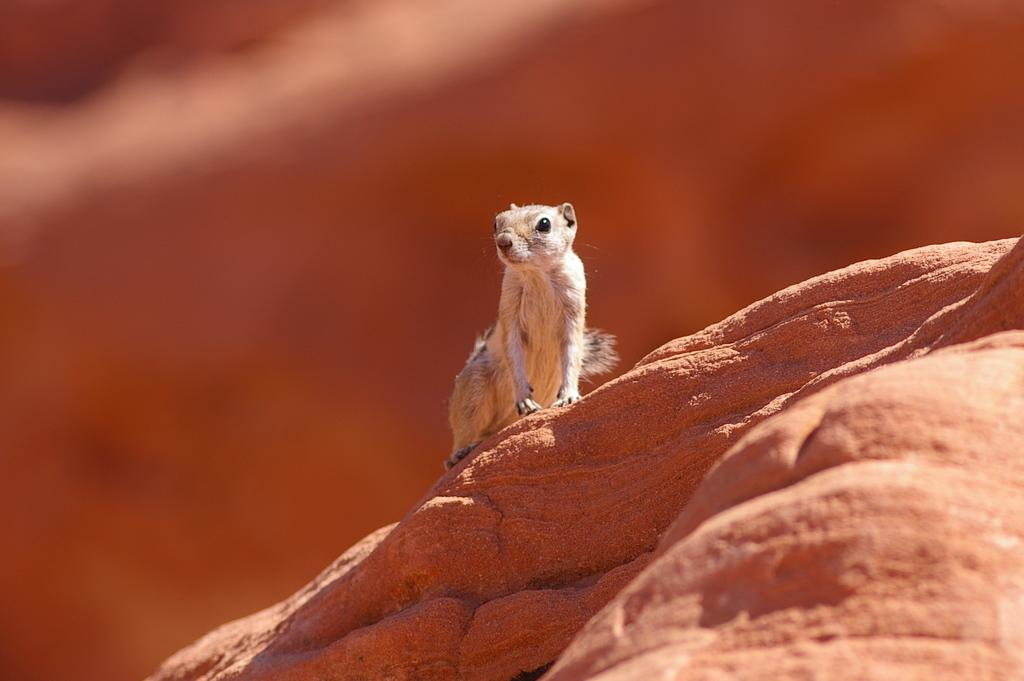What animal can be seen in the image? There is a squirrel in the image. Where is the squirrel located? The squirrel is on a rock. Can you describe the background of the image? The background of the image is blurred. What type of farm can be seen in the background of the image? There is no farm present in the image; the background is blurred. Is the squirrel a spy in the image? There is no indication in the image that the squirrel is a spy, as it is simply sitting on a rock. 